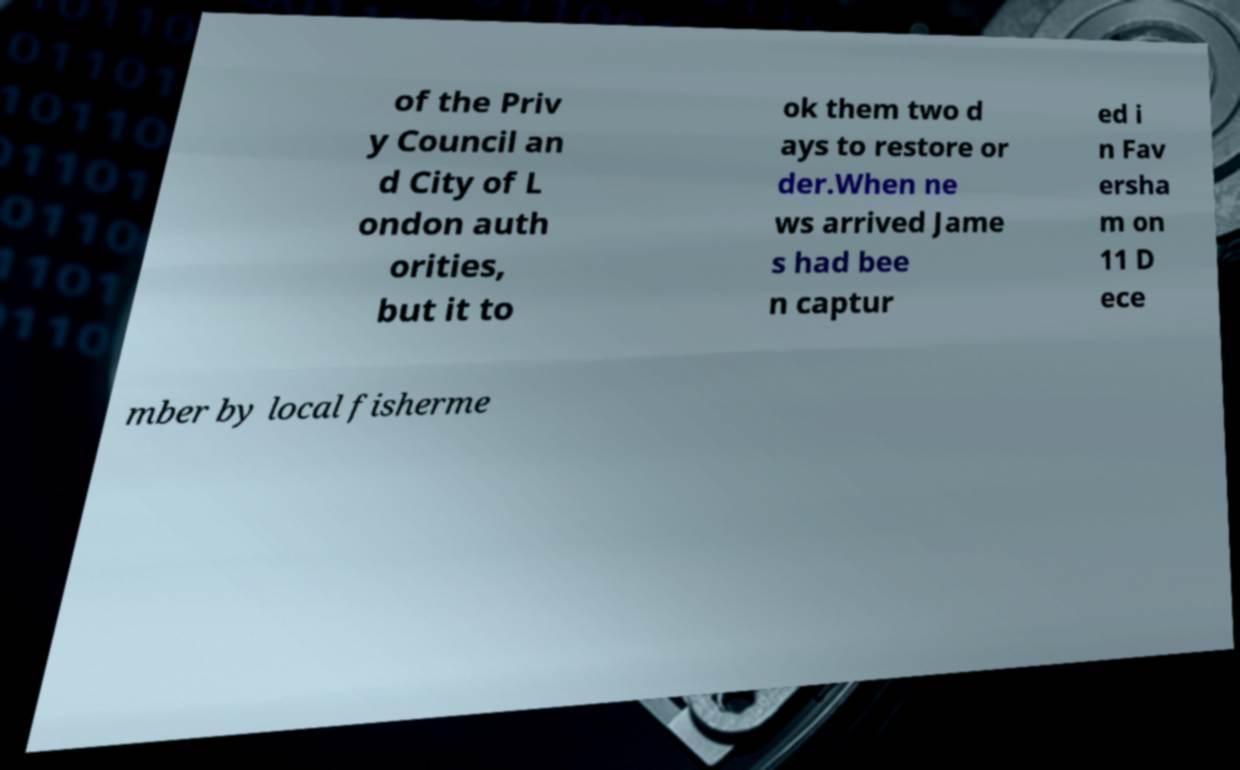Please identify and transcribe the text found in this image. of the Priv y Council an d City of L ondon auth orities, but it to ok them two d ays to restore or der.When ne ws arrived Jame s had bee n captur ed i n Fav ersha m on 11 D ece mber by local fisherme 